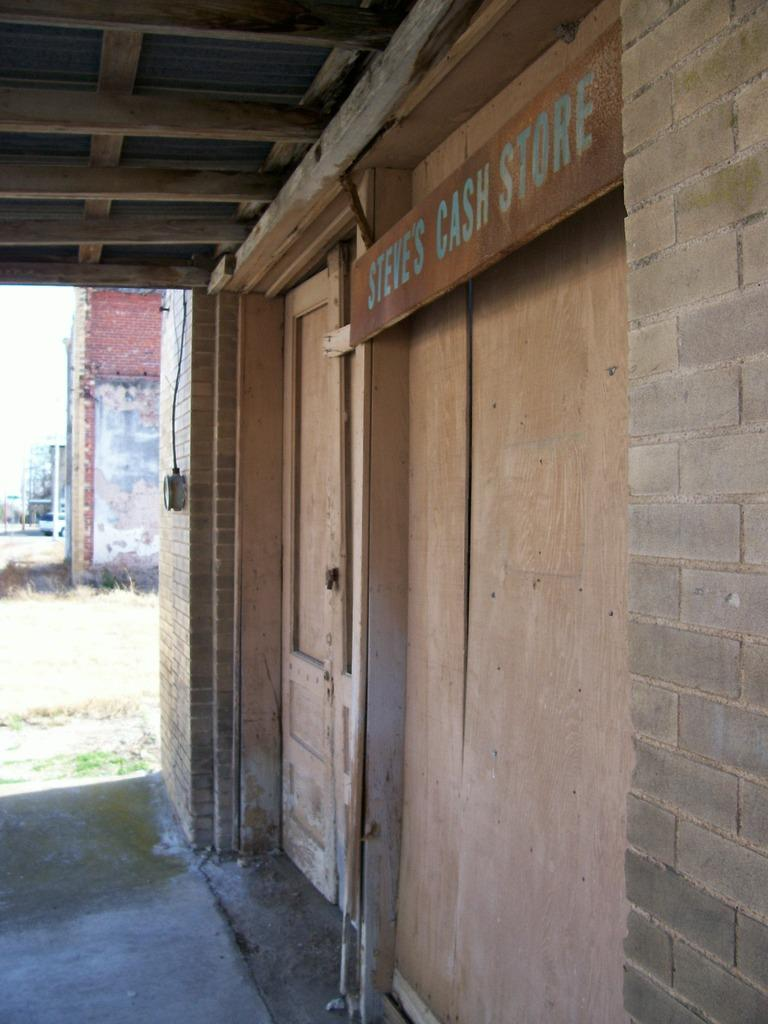What type of structures can be seen in the image? There are buildings in the image. Can you describe a specific feature of one of the buildings? There is a door visible on one of the buildings. What is written on the board in the image? There is a board with text written on it in the image. What type of ground surface is visible in the image? There is grass on the ground in the image. What books are being displayed during the show in the image? There is no show or books present in the image. 